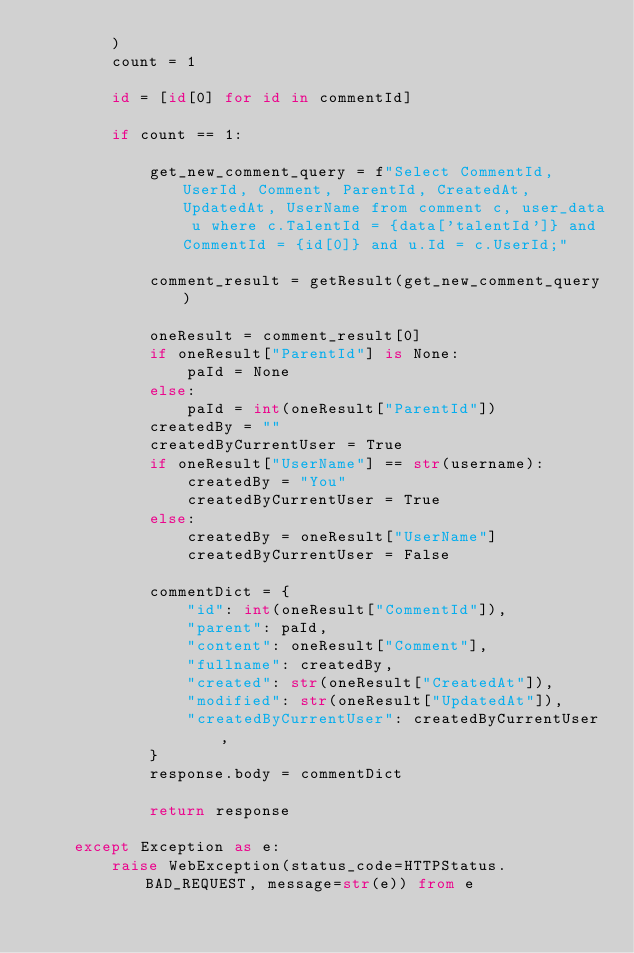Convert code to text. <code><loc_0><loc_0><loc_500><loc_500><_Python_>        )
        count = 1

        id = [id[0] for id in commentId]

        if count == 1:

            get_new_comment_query = f"Select CommentId, UserId, Comment, ParentId, CreatedAt, UpdatedAt, UserName from comment c, user_data u where c.TalentId = {data['talentId']} and CommentId = {id[0]} and u.Id = c.UserId;"

            comment_result = getResult(get_new_comment_query)

            oneResult = comment_result[0]
            if oneResult["ParentId"] is None:
                paId = None
            else:
                paId = int(oneResult["ParentId"])
            createdBy = ""
            createdByCurrentUser = True
            if oneResult["UserName"] == str(username):
                createdBy = "You"
                createdByCurrentUser = True
            else:
                createdBy = oneResult["UserName"]
                createdByCurrentUser = False

            commentDict = {
                "id": int(oneResult["CommentId"]),
                "parent": paId,
                "content": oneResult["Comment"],
                "fullname": createdBy,
                "created": str(oneResult["CreatedAt"]),
                "modified": str(oneResult["UpdatedAt"]),
                "createdByCurrentUser": createdByCurrentUser,
            }
            response.body = commentDict

            return response

    except Exception as e:
        raise WebException(status_code=HTTPStatus.BAD_REQUEST, message=str(e)) from e
</code> 